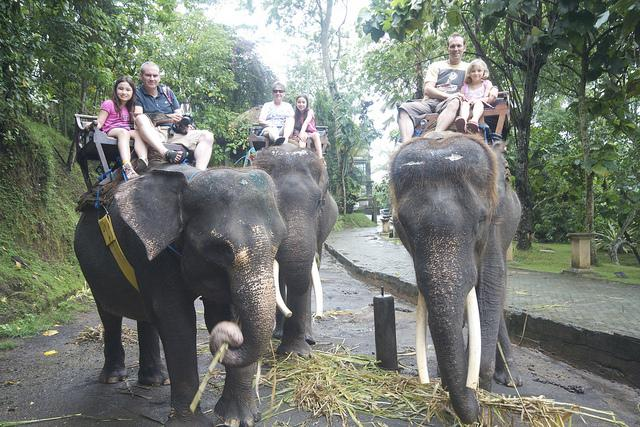What is hoisted atop the elephants to help the people ride them?

Choices:
A) saddles
B) benches
C) harnesses
D) blankets benches 